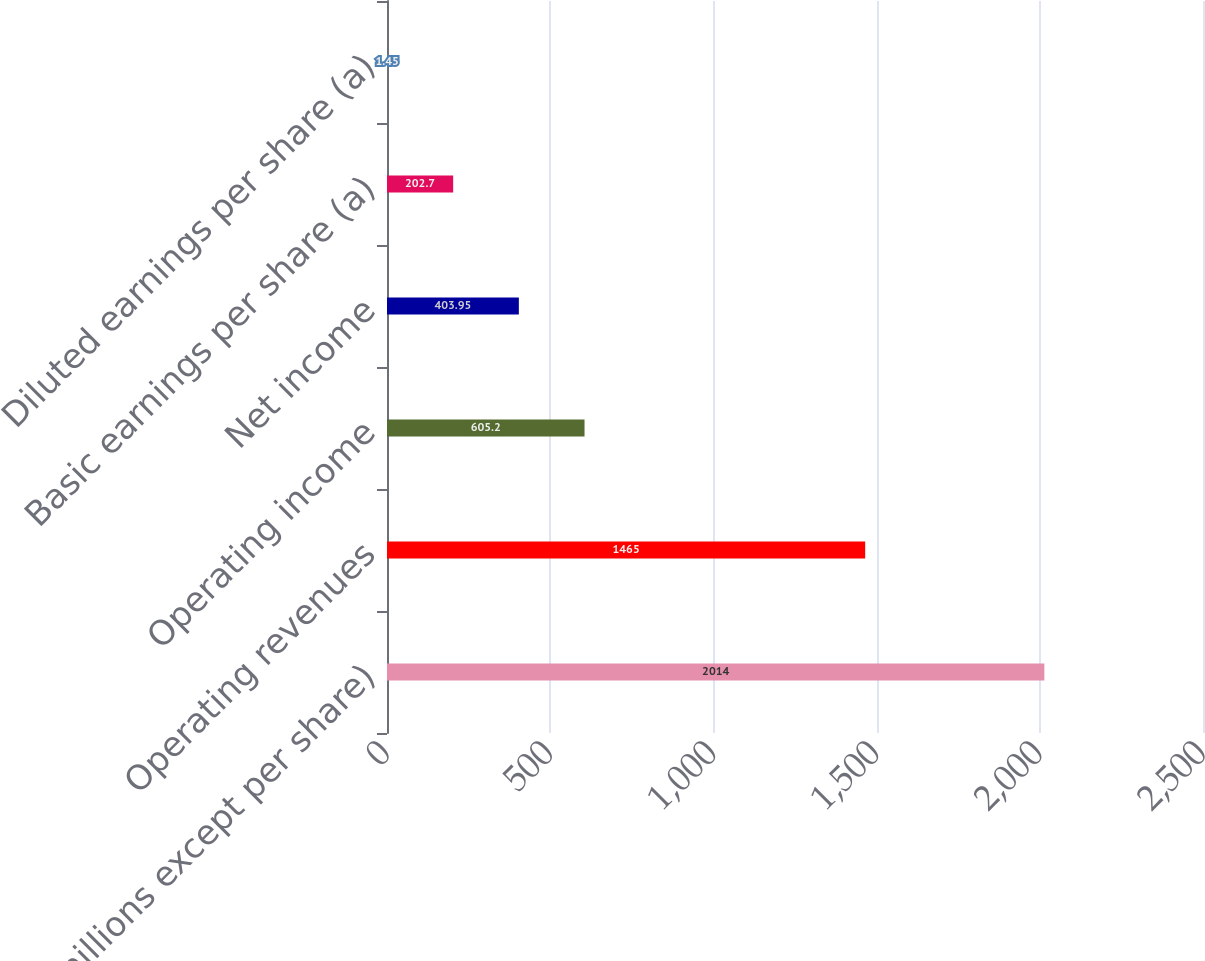Convert chart. <chart><loc_0><loc_0><loc_500><loc_500><bar_chart><fcel>(in millions except per share)<fcel>Operating revenues<fcel>Operating income<fcel>Net income<fcel>Basic earnings per share (a)<fcel>Diluted earnings per share (a)<nl><fcel>2014<fcel>1465<fcel>605.2<fcel>403.95<fcel>202.7<fcel>1.45<nl></chart> 